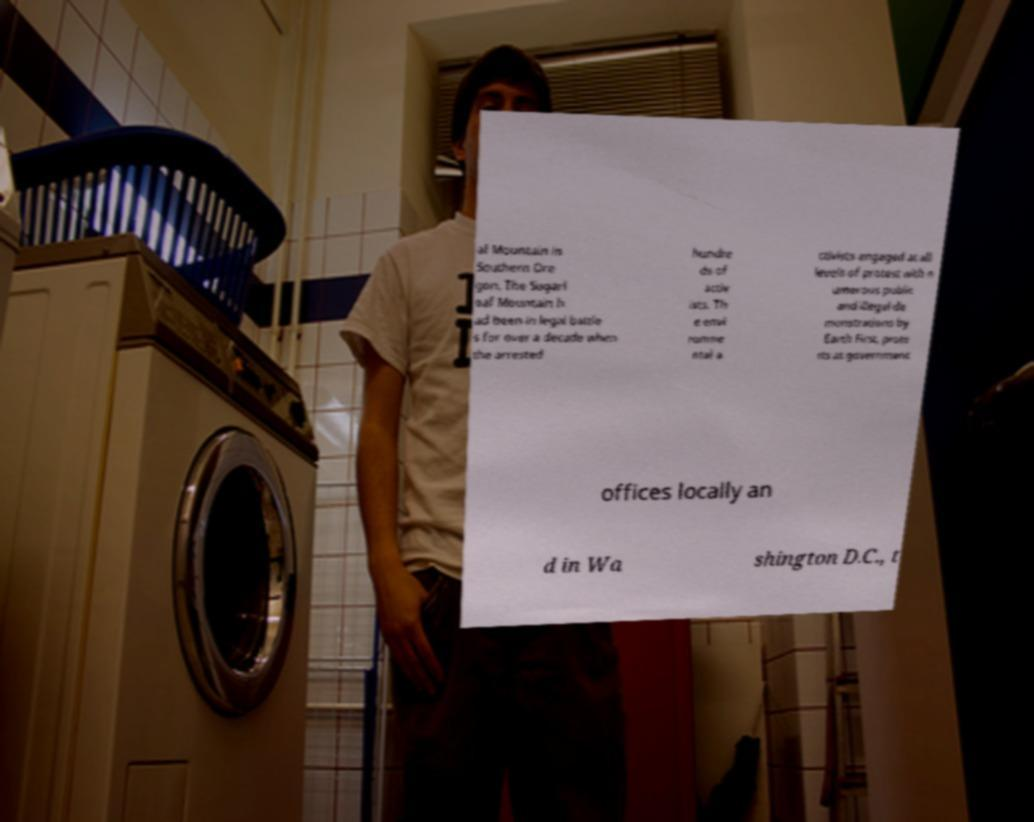I need the written content from this picture converted into text. Can you do that? af Mountain in Southern Ore gon. The Sugarl oaf Mountain h ad been in legal battle s for over a decade when the arrested hundre ds of activ ists. Th e envi ronme ntal a ctivists engaged at all levels of protest with n umerous public and illegal de monstrations by Earth First, prote sts at government offices locally an d in Wa shington D.C., t 